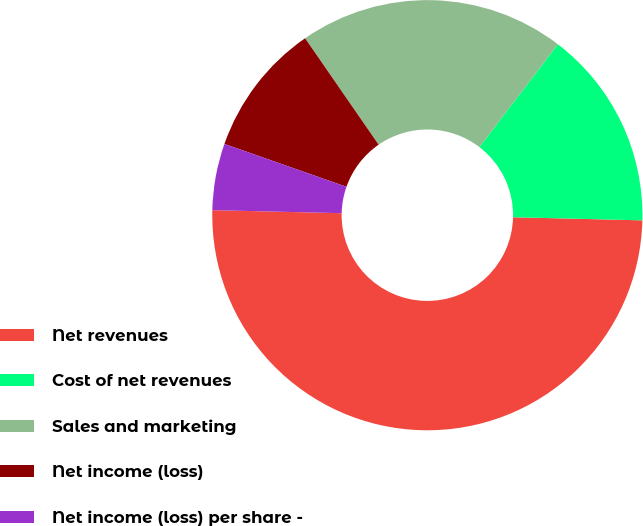Convert chart to OTSL. <chart><loc_0><loc_0><loc_500><loc_500><pie_chart><fcel>Net revenues<fcel>Cost of net revenues<fcel>Sales and marketing<fcel>Net income (loss)<fcel>Net income (loss) per share -<nl><fcel>49.99%<fcel>15.0%<fcel>20.0%<fcel>10.0%<fcel>5.0%<nl></chart> 